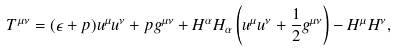<formula> <loc_0><loc_0><loc_500><loc_500>T ^ { \mu \nu } = ( \epsilon + p ) u ^ { \mu } u ^ { \nu } + p g ^ { \mu \nu } + H ^ { \alpha } H _ { \alpha } \left ( u ^ { \mu } u ^ { \nu } + \frac { 1 } { 2 } g ^ { \mu \nu } \right ) - H ^ { \mu } H ^ { \nu } ,</formula> 